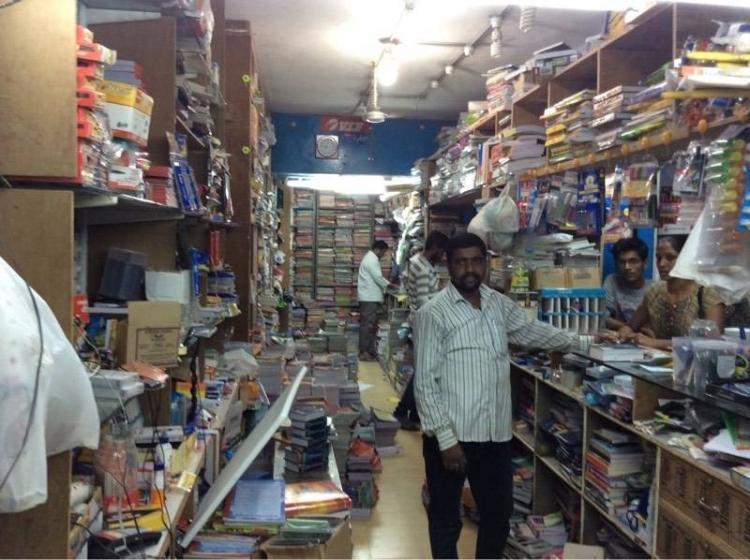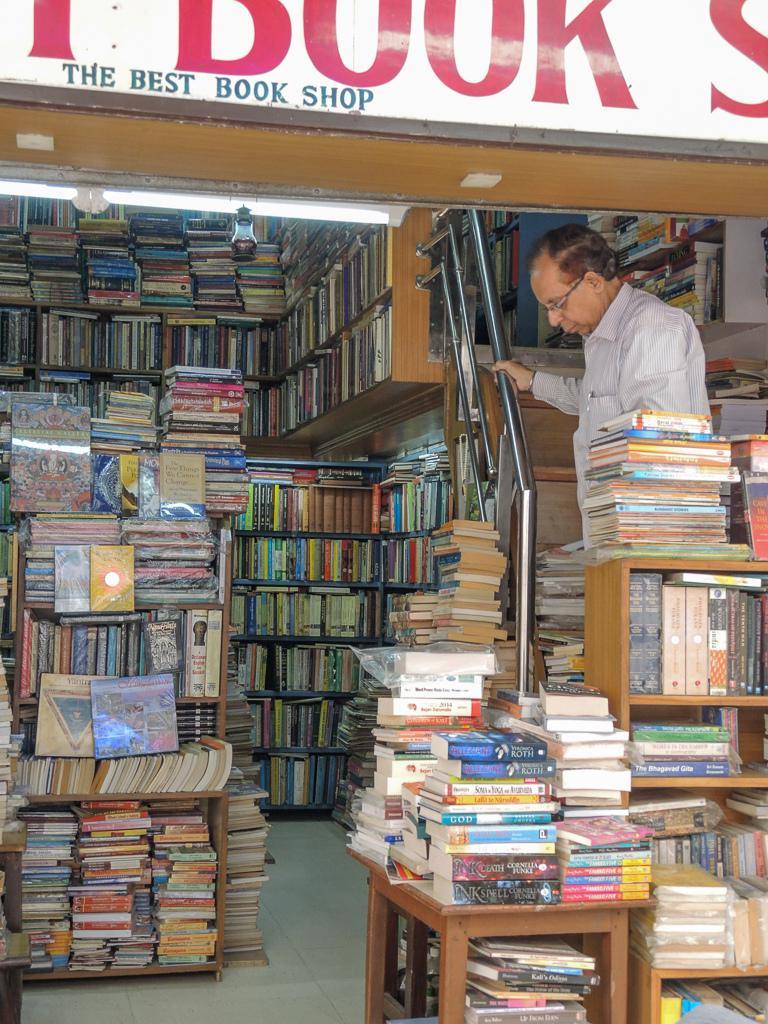The first image is the image on the left, the second image is the image on the right. Examine the images to the left and right. Is the description "One image has a man facing left and looking down." accurate? Answer yes or no. Yes. 